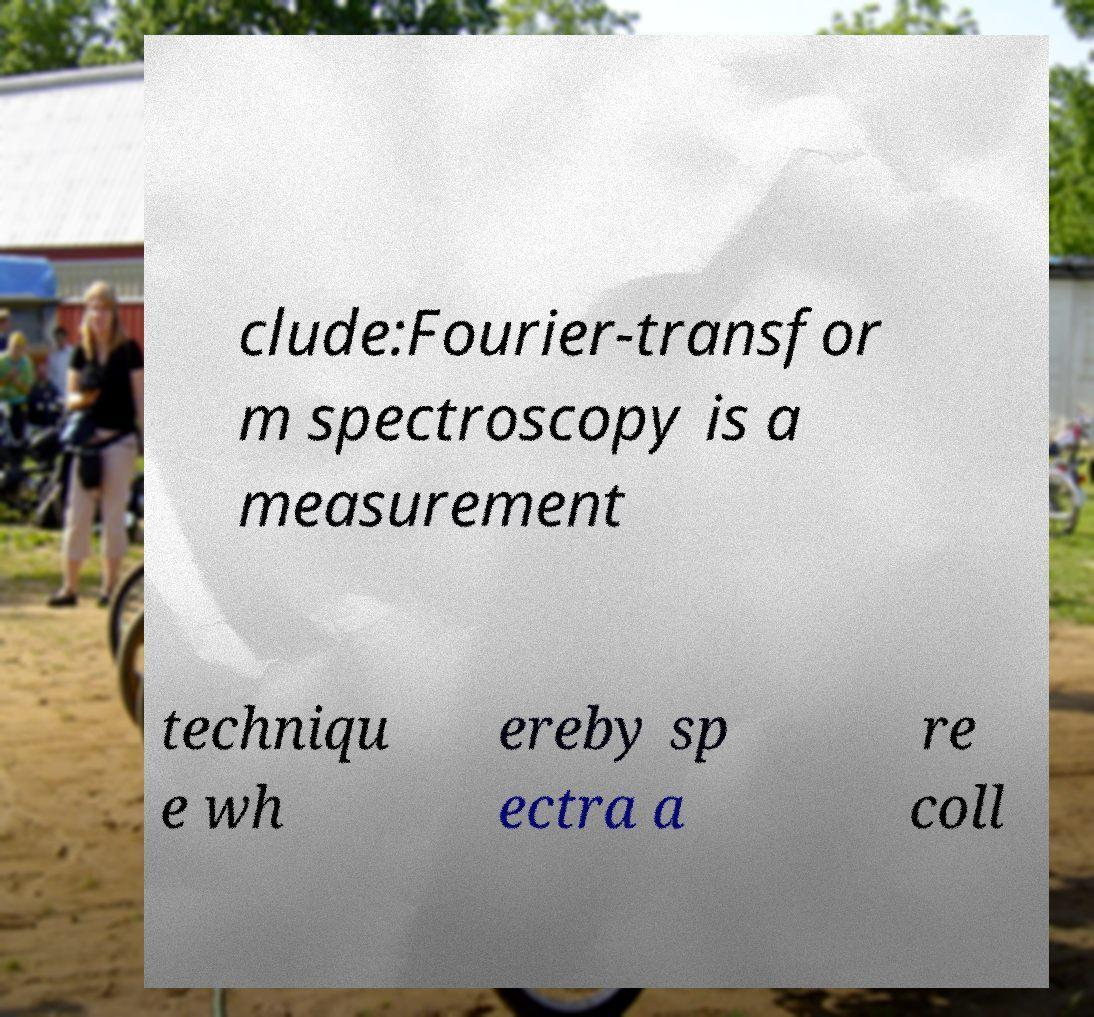Please identify and transcribe the text found in this image. clude:Fourier-transfor m spectroscopy is a measurement techniqu e wh ereby sp ectra a re coll 